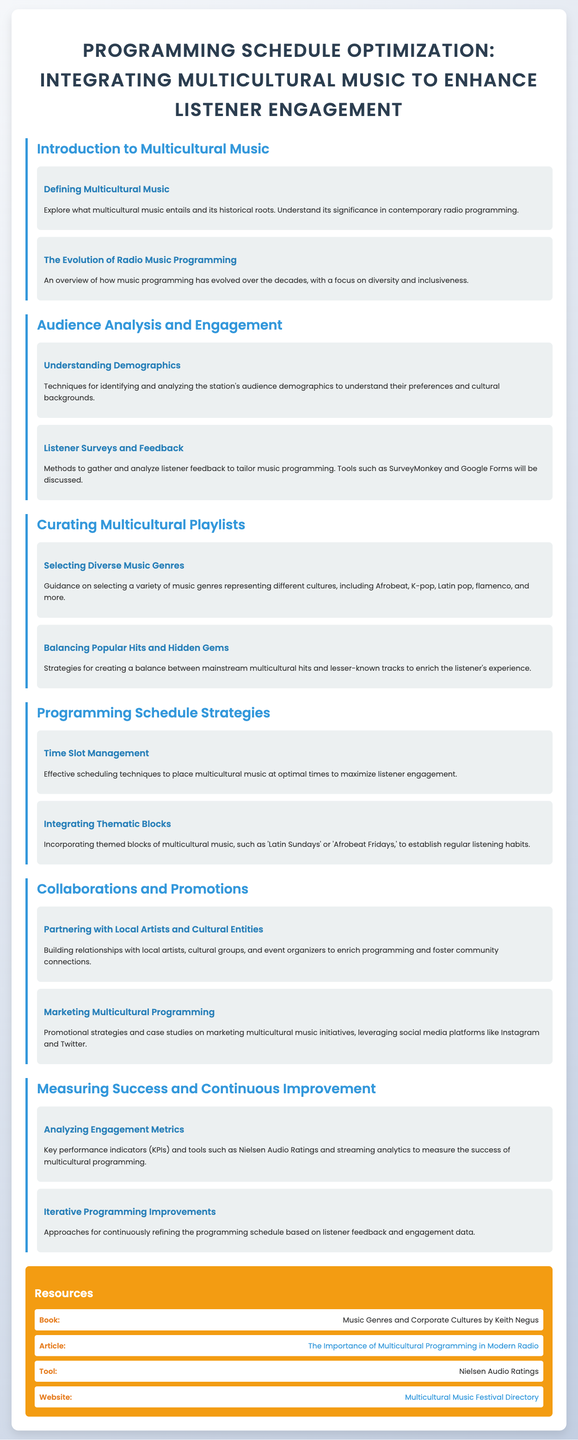what is the title of the syllabus? The title is found at the top of the document, summarizing its purpose.
Answer: Programming Schedule Optimization: Integrating Multicultural Music to Enhance Listener Engagement what are the names of two multicultural music genres mentioned? The syllabus lists various multicultural music genres as examples.
Answer: Afrobeat, K-pop what is one method discussed for gathering listener feedback? The document states several tools used to gather feedback from listeners.
Answer: SurveyMonkey what is the focus of the "Understanding Demographics" topic? This topic covers techniques for analyzing the audience's cultural backgrounds.
Answer: Identifying and analyzing the station's audience demographics which organization’s tool is mentioned for analyzing engagement metrics? The syllabus provides a specific organization's tool for measuring success in programming.
Answer: Nielsen Audio Ratings how does the syllabus suggest promoting multicultural programming? The document discusses a method for marketing initiatives in multicultural music.
Answer: Leveraging social media platforms what is one strategy for playlist curation mentioned in the document? The syllabus notes strategies aimed at balancing different types of music.
Answer: Balancing Popular Hits and Hidden Gems what is the first module of the syllabus? The modules in the syllabus are listed in a specific order starting with the introduction.
Answer: Introduction to Multicultural Music what is highlighted as a benefit of integrating thematic blocks? The document describes outcomes expected from using thematic blocks in programming.
Answer: Establish regular listening habits 